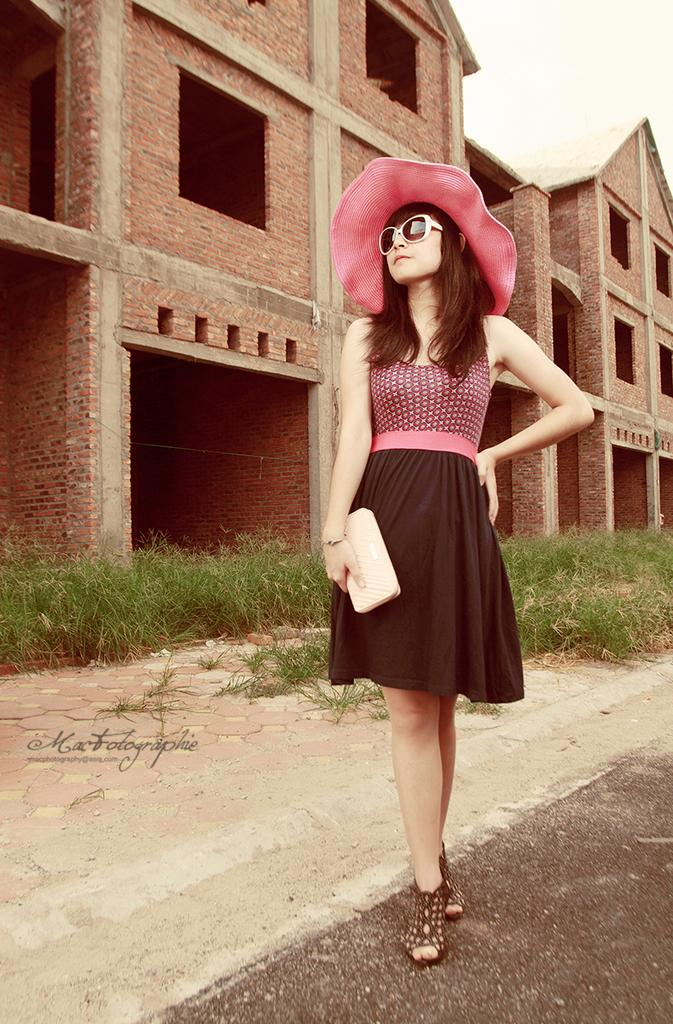Who is present in the image? There is a woman in the image. What is the woman holding? The woman is holding a purse. What can be seen in the background of the image? There are houses and grass in the background of the image. What is visible in the sky? The sky is visible in the image. Is there any text present in the image? Yes, there is text on the image. What type of scarf is the woman wearing in the image? There is no scarf visible in the image; the woman is holding a purse. How does the soap in the image contribute to the scene? There is no soap present in the image. 